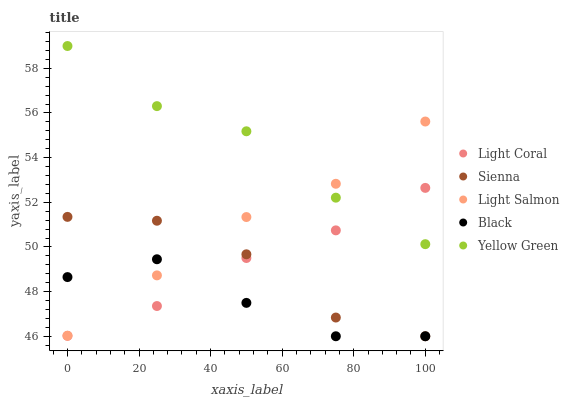Does Black have the minimum area under the curve?
Answer yes or no. Yes. Does Yellow Green have the maximum area under the curve?
Answer yes or no. Yes. Does Sienna have the minimum area under the curve?
Answer yes or no. No. Does Sienna have the maximum area under the curve?
Answer yes or no. No. Is Light Coral the smoothest?
Answer yes or no. Yes. Is Black the roughest?
Answer yes or no. Yes. Is Sienna the smoothest?
Answer yes or no. No. Is Sienna the roughest?
Answer yes or no. No. Does Sienna have the lowest value?
Answer yes or no. Yes. Does Light Salmon have the lowest value?
Answer yes or no. No. Does Yellow Green have the highest value?
Answer yes or no. Yes. Does Sienna have the highest value?
Answer yes or no. No. Is Sienna less than Yellow Green?
Answer yes or no. Yes. Is Yellow Green greater than Black?
Answer yes or no. Yes. Does Sienna intersect Light Salmon?
Answer yes or no. Yes. Is Sienna less than Light Salmon?
Answer yes or no. No. Is Sienna greater than Light Salmon?
Answer yes or no. No. Does Sienna intersect Yellow Green?
Answer yes or no. No. 